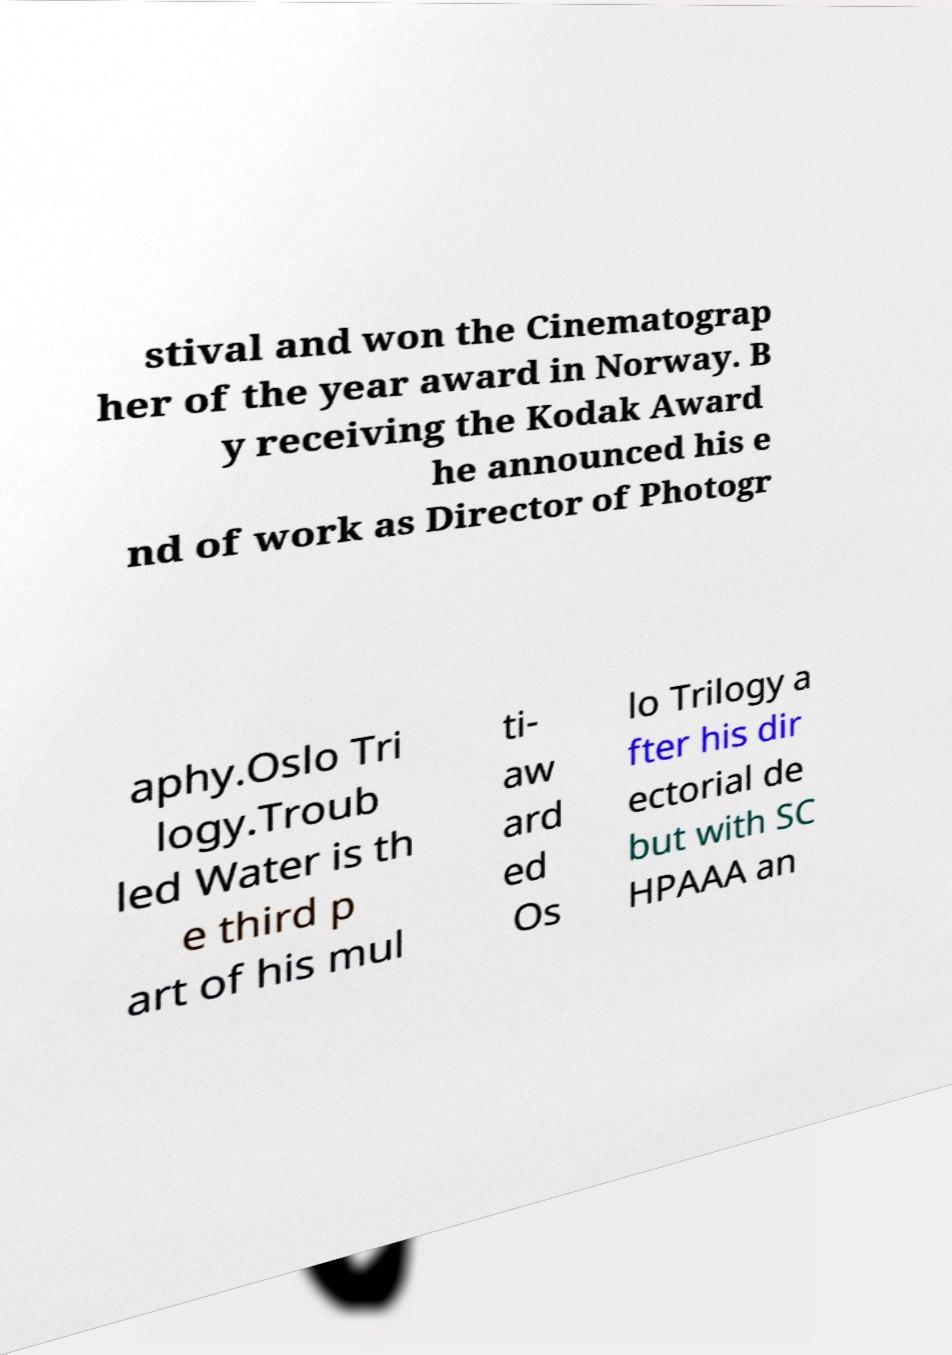Can you read and provide the text displayed in the image?This photo seems to have some interesting text. Can you extract and type it out for me? stival and won the Cinematograp her of the year award in Norway. B y receiving the Kodak Award he announced his e nd of work as Director of Photogr aphy.Oslo Tri logy.Troub led Water is th e third p art of his mul ti- aw ard ed Os lo Trilogy a fter his dir ectorial de but with SC HPAAA an 